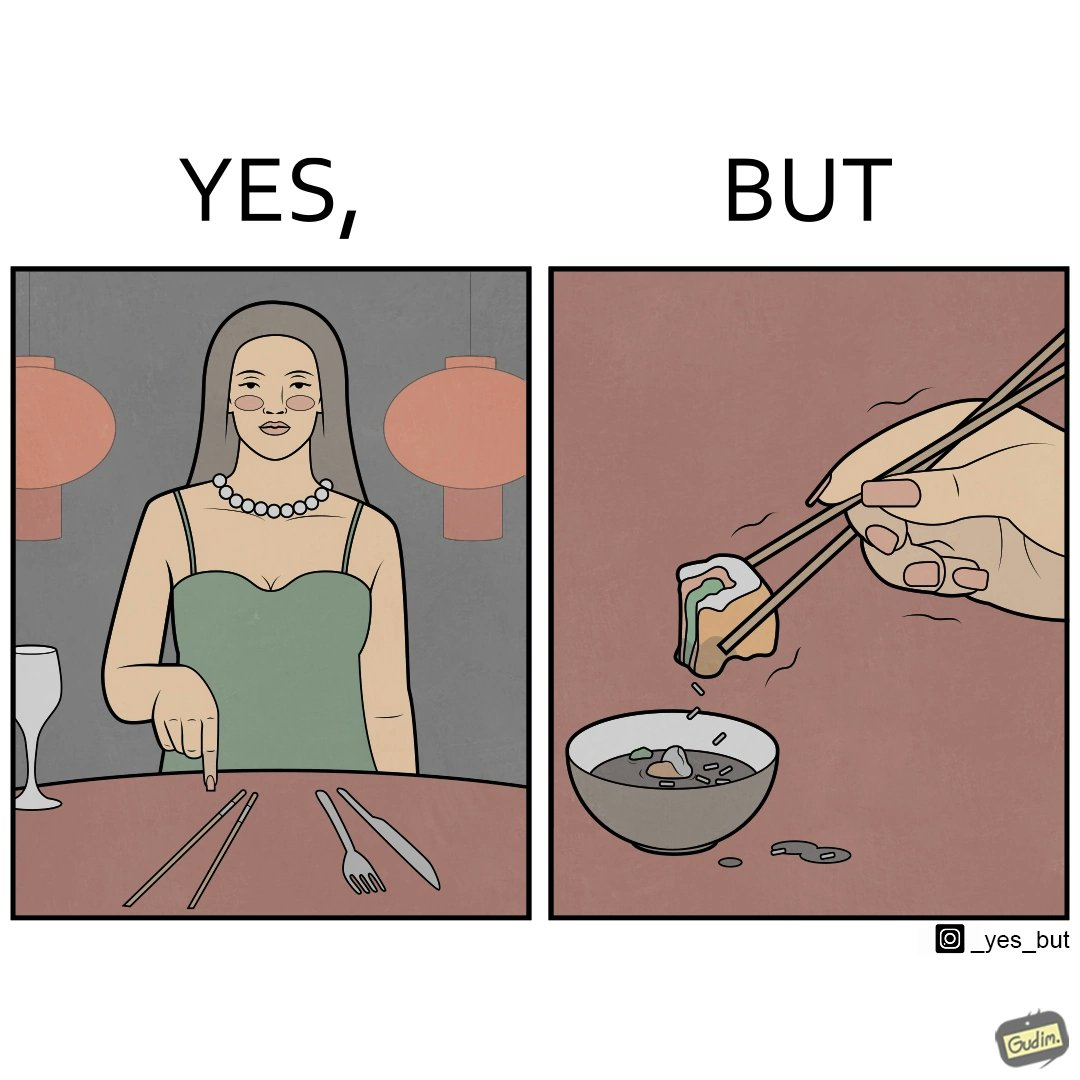What does this image depict? The image is satirical because even thought the woman is not able to eat food with chopstick properly, she chooses it over fork and knife to look sophisticaed. 